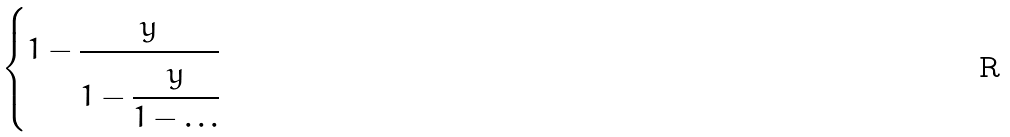<formula> <loc_0><loc_0><loc_500><loc_500>\begin{cases} 1 - \cfrac { y } { 1 - \cfrac { y } { 1 - \dots } } \end{cases}</formula> 